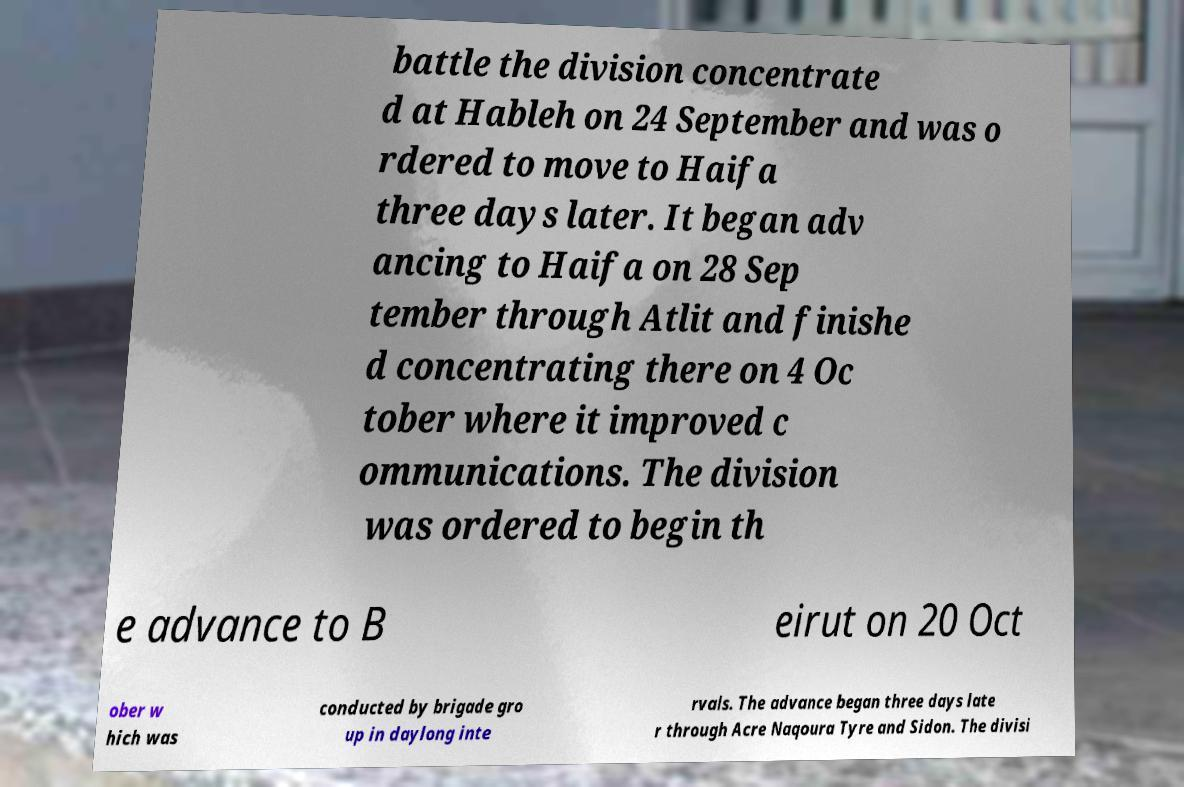Could you assist in decoding the text presented in this image and type it out clearly? battle the division concentrate d at Hableh on 24 September and was o rdered to move to Haifa three days later. It began adv ancing to Haifa on 28 Sep tember through Atlit and finishe d concentrating there on 4 Oc tober where it improved c ommunications. The division was ordered to begin th e advance to B eirut on 20 Oct ober w hich was conducted by brigade gro up in daylong inte rvals. The advance began three days late r through Acre Naqoura Tyre and Sidon. The divisi 